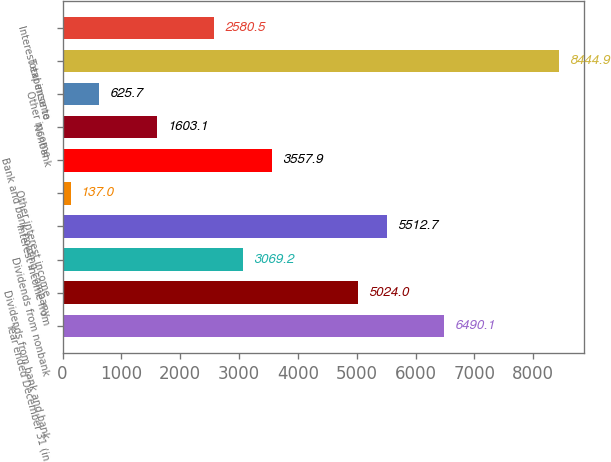Convert chart to OTSL. <chart><loc_0><loc_0><loc_500><loc_500><bar_chart><fcel>Year ended December 31 (in<fcel>Dividends from bank and bank<fcel>Dividends from nonbank<fcel>Interest income from<fcel>Other interest income<fcel>Bank and bank holding company<fcel>Nonbank<fcel>Other income<fcel>Total income<fcel>Interest expense to<nl><fcel>6490.1<fcel>5024<fcel>3069.2<fcel>5512.7<fcel>137<fcel>3557.9<fcel>1603.1<fcel>625.7<fcel>8444.9<fcel>2580.5<nl></chart> 